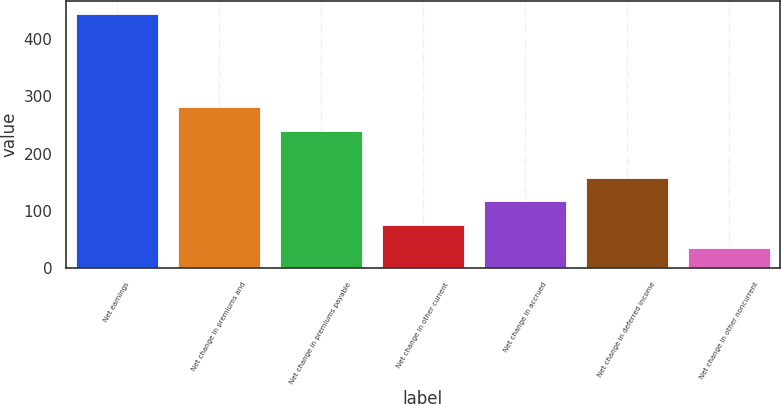<chart> <loc_0><loc_0><loc_500><loc_500><bar_chart><fcel>Net earnings<fcel>Net change in premiums and<fcel>Net change in premiums payable<fcel>Net change in other current<fcel>Net change in accrued<fcel>Net change in deferred income<fcel>Net change in other noncurrent<nl><fcel>445<fcel>281.25<fcel>240.2<fcel>75.55<fcel>116.6<fcel>158<fcel>34.5<nl></chart> 